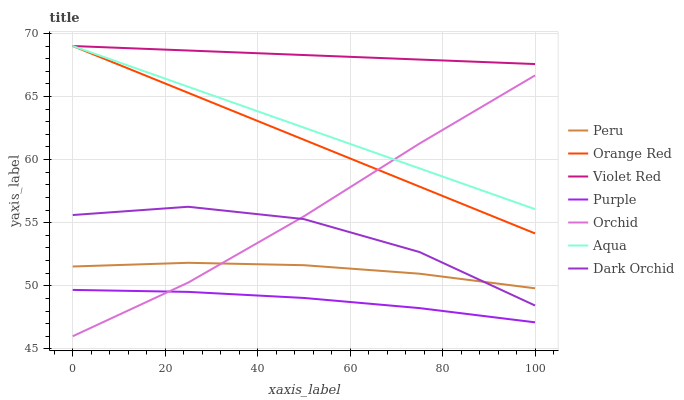Does Aqua have the minimum area under the curve?
Answer yes or no. No. Does Aqua have the maximum area under the curve?
Answer yes or no. No. Is Purple the smoothest?
Answer yes or no. No. Is Purple the roughest?
Answer yes or no. No. Does Purple have the lowest value?
Answer yes or no. No. Does Purple have the highest value?
Answer yes or no. No. Is Peru less than Aqua?
Answer yes or no. Yes. Is Violet Red greater than Purple?
Answer yes or no. Yes. Does Peru intersect Aqua?
Answer yes or no. No. 